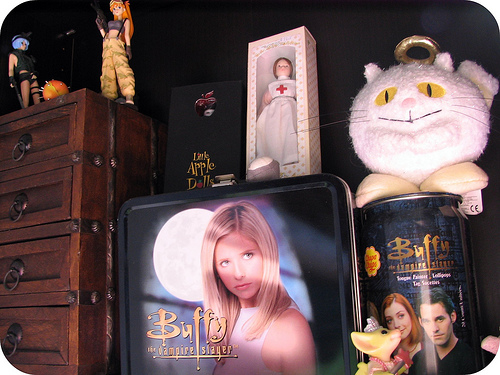<image>
Is the cat on the dresser? No. The cat is not positioned on the dresser. They may be near each other, but the cat is not supported by or resting on top of the dresser. 